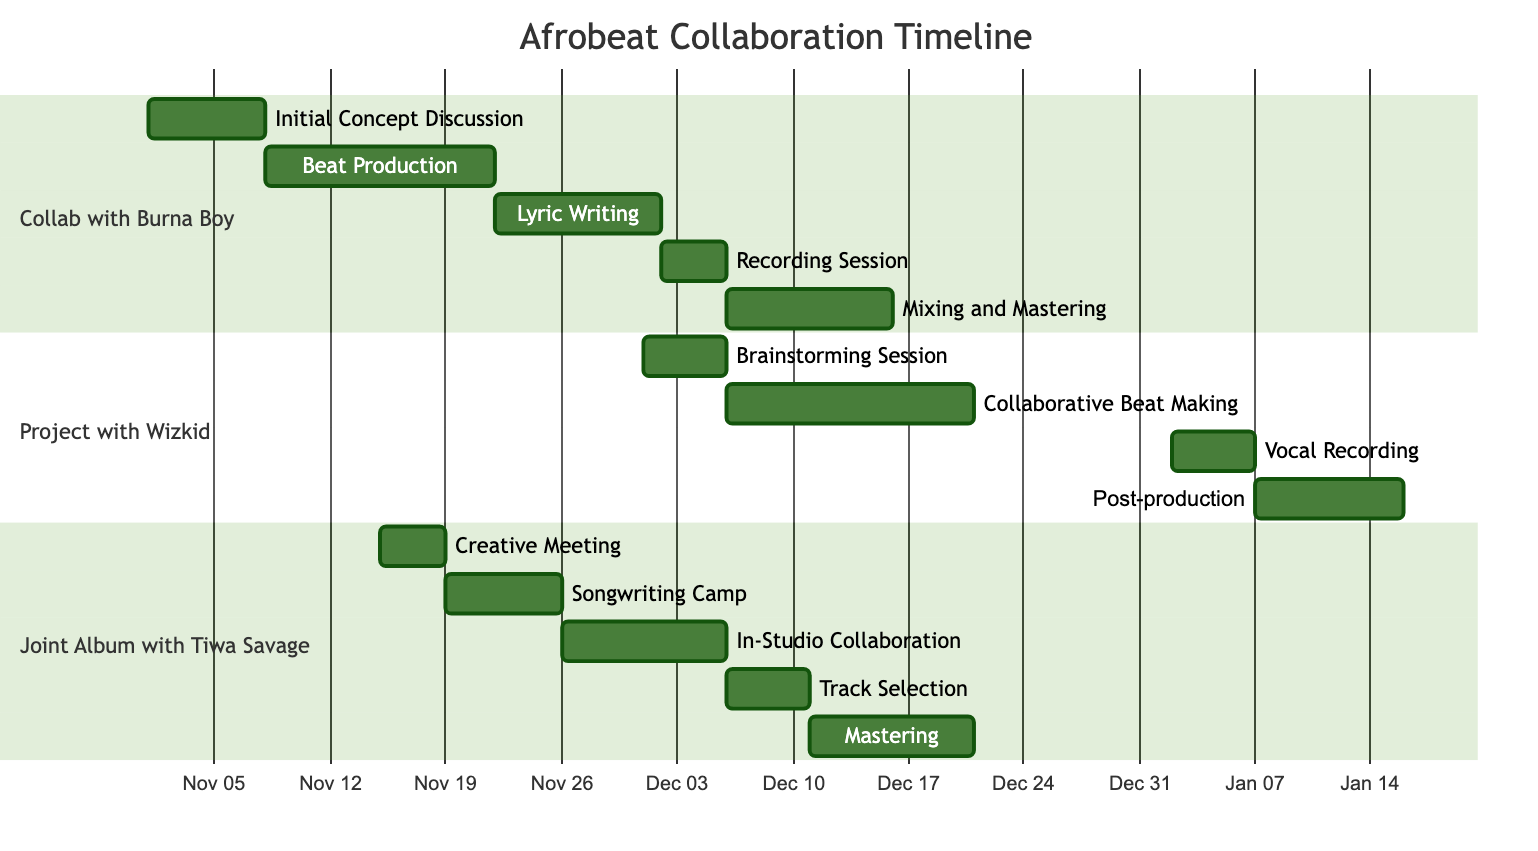What is the duration of the "Beat Production" task? The Gantt chart shows that "Beat Production" starts on November 8, 2023, and ends on November 21, 2023. The duration can be calculated by subtracting the start date from the end date, resulting in a total of 14 days.
Answer: 14 days When does the "Vocal Recording" task take place? To find the date of the "Vocal Recording" task, we can look specifically at the section for the project with Wizkid, which states that this task starts on January 2, 2024, and ends on January 6, 2024.
Answer: January 2, 2024 Which task overlaps with "Mixing and Mastering"? "Mixing and Mastering" is scheduled from December 6, 2023, to December 15, 2023. To determine overlaps, we check the tasks before and after these dates. Both "In-Studio Collaboration" (December 6 to December 5) and "Track Selection" (December 6 to December 10) start on the same date, December 6, 2023, meaning they overlap with "Mixing and Mastering".
Answer: In-Studio Collaboration, Track Selection How many tasks are part of the "Joint Album with Tiwa Savage"? The section for "Joint Album with Tiwa Savage" contains five tasks: Creative Meeting, Songwriting Camp, In-Studio Collaboration, Track Selection, and Mastering. Counting these tasks gives us the total number of tasks for this project.
Answer: 5 tasks What is the end date of the "Songwriting Camp"? The "Songwriting Camp" is listed in the "Joint Album with Tiwa Savage" section and has a start date of November 19, 2023, and an end date of November 25, 2023. Therefore, we can find the end date directly in this task's details.
Answer: November 25, 2023 Which project has tasks scheduled for December 6, 2023? By examining the tasks in both the "Collab with Burna Boy" and "Project with Wizkid", we see that "Mixing and Mastering" (Burna Boy) and "Collaborative Beat Making" (Wizkid) both start on December 6, 2023. This project has tasks scheduled for this date.
Answer: Both projects What is the total duration of the "Project with Wizkid"? To determine the total duration, we add the lengths of all four tasks: Brainstorming Session (5 days), Collaborative Beat Making (15 days), Vocal Recording (5 days), and Post-production (9 days). This results in a total of 34 days for the entire project.
Answer: 34 days What is the earliest start date among all tasks? The earliest task in the entire Gantt chart is "Initial Concept Discussion," which starts on November 1, 2023. Comparing all tasks' start dates, we find that this is the earliest, confirming it has the lowest date.
Answer: November 1, 2023 